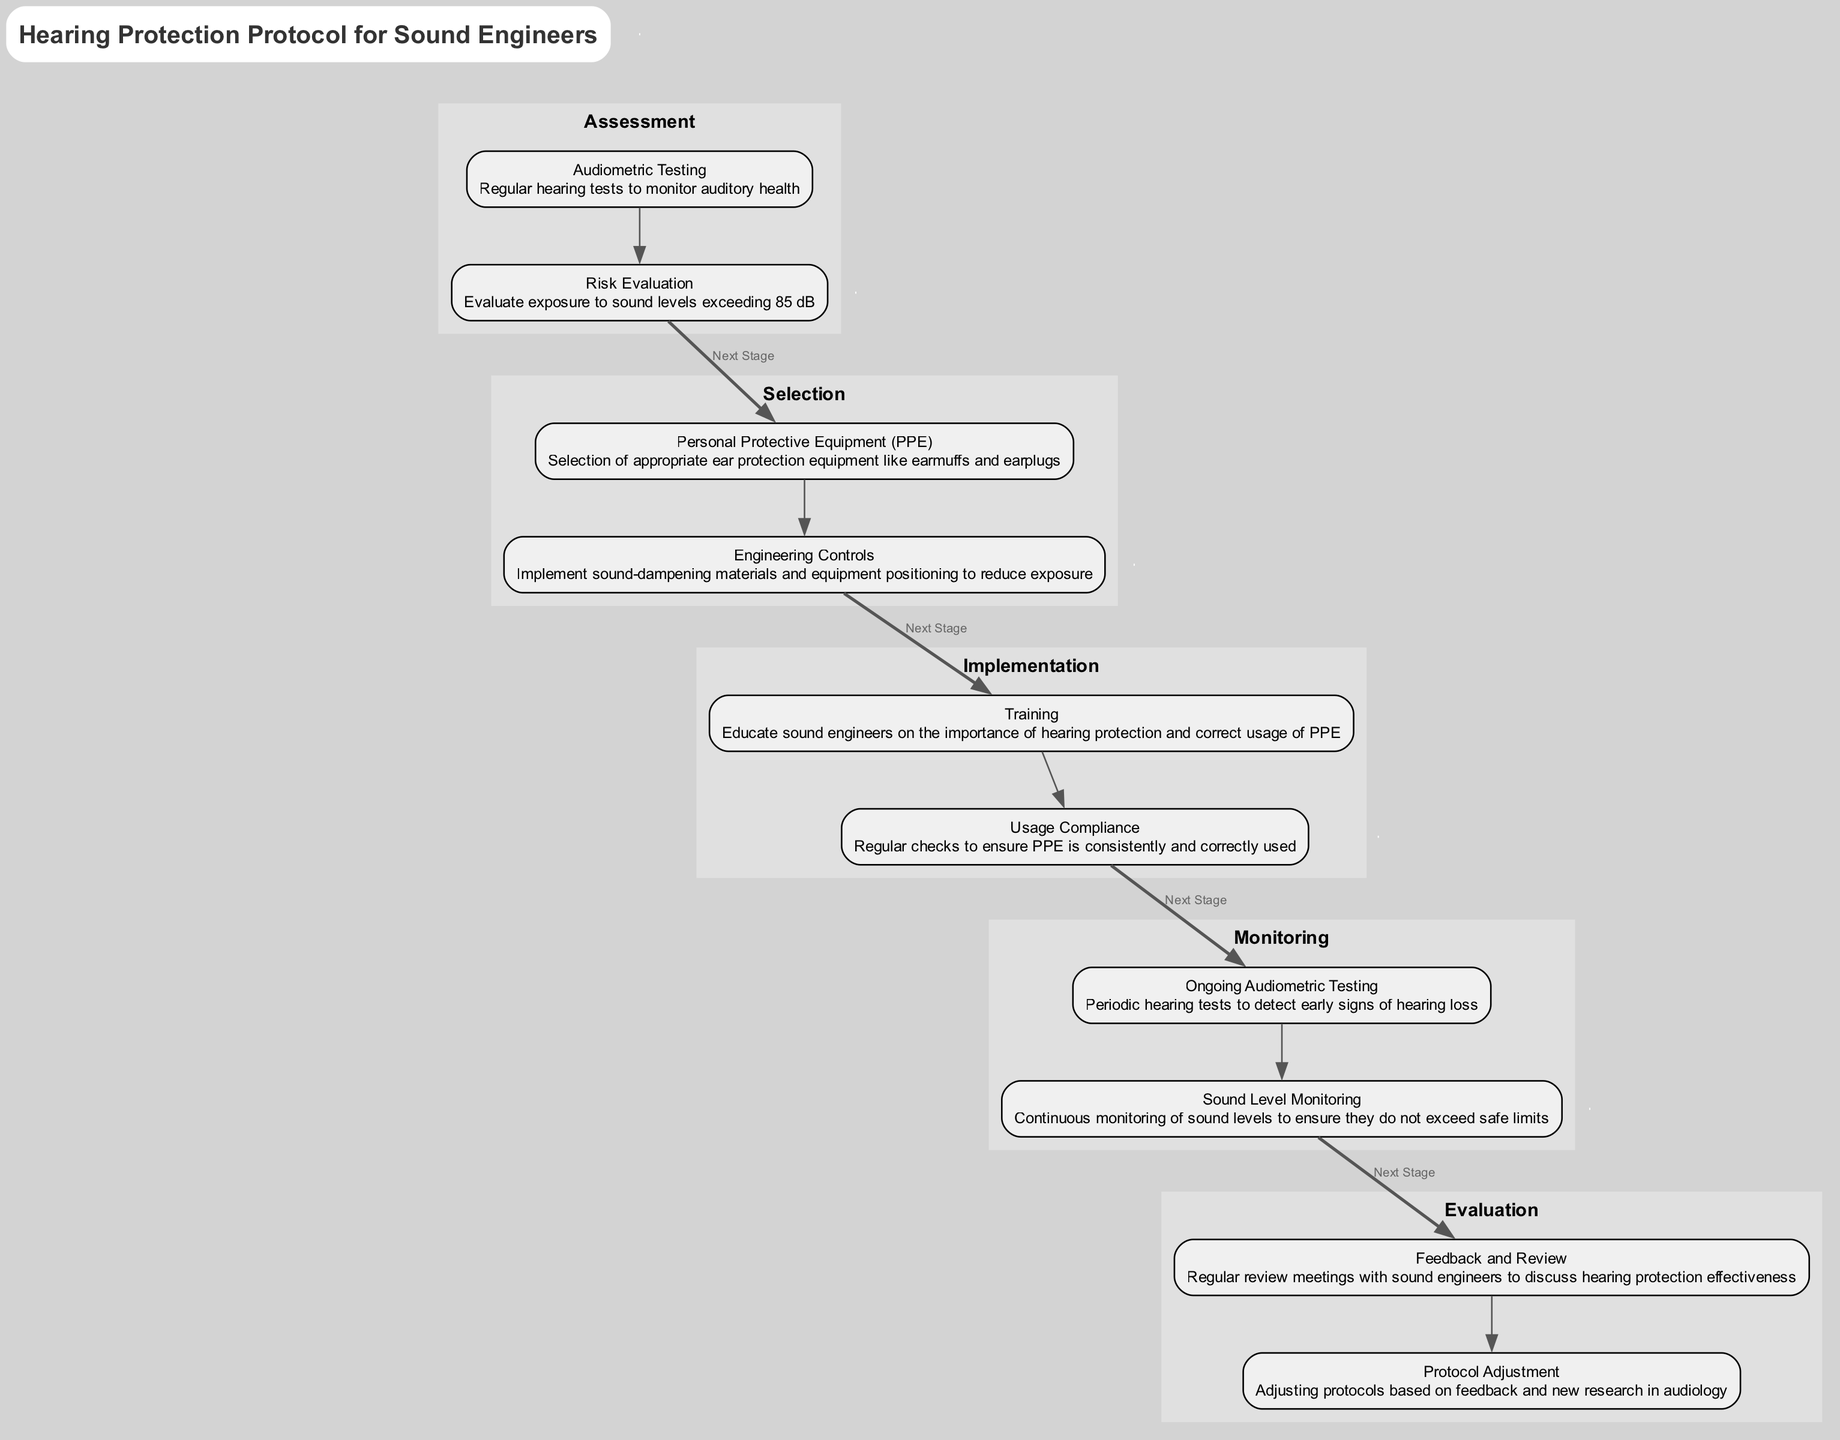What is the first stage in the pathway? The first stage listed in the diagram is "Assessment". It is identified as the initial stage before the others, indicating the starting point of the clinical pathway.
Answer: Assessment How many elements are there in the "Selection" stage? The "Selection" stage contains two elements: "Personal Protective Equipment (PPE)" and "Engineering Controls". The count of elements is taken directly from the stage section of the diagram.
Answer: 2 What is the purpose of ongoing audiometric testing? The purpose is to detect early signs of hearing loss. This is explicitly stated in the description for the "Ongoing Audiometric Testing" element within the "Monitoring" stage.
Answer: Detect early signs of hearing loss Which stage comes after "Implementation"? The stage that follows "Implementation" in the clinical pathway is "Monitoring". This can be found by tracing the connection from the last element of the "Implementation" stage to the first element of the "Monitoring" stage.
Answer: Monitoring What is one method of reducing sound exposure listed in the "Selection" stage? One method mentioned is "Engineering Controls". This element describes implementing sound-dampening materials and equipment positioning to mitigate exposure to high sound levels.
Answer: Engineering Controls How many total stages are in the pathway? There are five stages in total: "Assessment", "Selection", "Implementation", "Monitoring", and "Evaluation". This count comes from the explicit listing of each stage in the diagram.
Answer: 5 What is the last element in the "Evaluation" stage? The last element in the "Evaluation" stage is "Protocol Adjustment". This is indicated as the last item under the "Evaluation" category in the diagram.
Answer: Protocol Adjustment Which stage involves training sound engineers? The "Implementation" stage involves training sound engineers. It specifically contains the "Training" element that focuses on education regarding hearing protection.
Answer: Implementation What is assessed in the "Risk Evaluation"? The "Risk Evaluation" assesses exposure to sound levels exceeding 85 dB. This is highlighted in the description of the corresponding element in the "Assessment" stage.
Answer: Exposure to sound levels exceeding 85 dB 